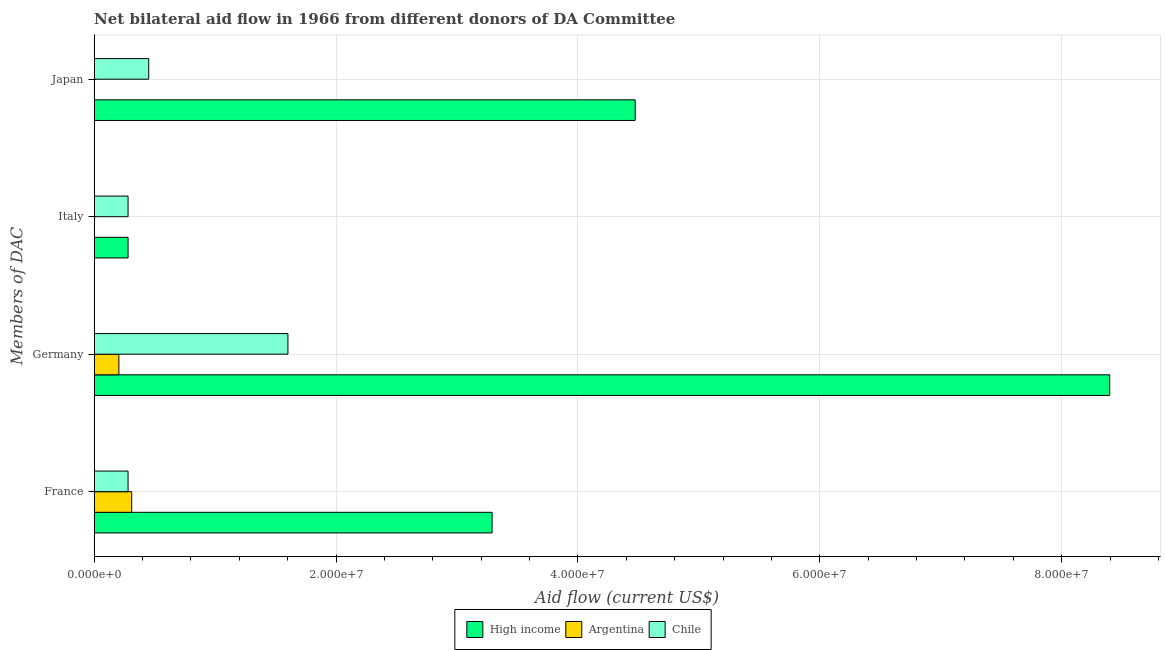Are the number of bars on each tick of the Y-axis equal?
Make the answer very short. No. How many bars are there on the 3rd tick from the top?
Give a very brief answer. 3. How many bars are there on the 2nd tick from the bottom?
Keep it short and to the point. 3. Across all countries, what is the maximum amount of aid given by germany?
Offer a terse response. 8.40e+07. Across all countries, what is the minimum amount of aid given by japan?
Give a very brief answer. 2.00e+04. In which country was the amount of aid given by japan maximum?
Provide a succinct answer. High income. What is the total amount of aid given by germany in the graph?
Keep it short and to the point. 1.02e+08. What is the difference between the amount of aid given by germany in Chile and that in High income?
Your answer should be very brief. -6.80e+07. What is the difference between the amount of aid given by germany in High income and the amount of aid given by italy in Chile?
Provide a short and direct response. 8.12e+07. What is the average amount of aid given by france per country?
Give a very brief answer. 1.29e+07. What is the difference between the amount of aid given by italy and amount of aid given by japan in High income?
Provide a short and direct response. -4.19e+07. In how many countries, is the amount of aid given by japan greater than 44000000 US$?
Provide a succinct answer. 1. Is the difference between the amount of aid given by italy in Chile and High income greater than the difference between the amount of aid given by france in Chile and High income?
Offer a very short reply. Yes. What is the difference between the highest and the second highest amount of aid given by germany?
Offer a terse response. 6.80e+07. What is the difference between the highest and the lowest amount of aid given by france?
Offer a very short reply. 3.01e+07. Is it the case that in every country, the sum of the amount of aid given by italy and amount of aid given by japan is greater than the sum of amount of aid given by france and amount of aid given by germany?
Offer a very short reply. No. Is it the case that in every country, the sum of the amount of aid given by france and amount of aid given by germany is greater than the amount of aid given by italy?
Offer a very short reply. Yes. Are all the bars in the graph horizontal?
Offer a very short reply. Yes. What is the difference between two consecutive major ticks on the X-axis?
Offer a terse response. 2.00e+07. Does the graph contain grids?
Make the answer very short. Yes. Where does the legend appear in the graph?
Make the answer very short. Bottom center. How many legend labels are there?
Make the answer very short. 3. How are the legend labels stacked?
Provide a succinct answer. Horizontal. What is the title of the graph?
Provide a succinct answer. Net bilateral aid flow in 1966 from different donors of DA Committee. Does "Vanuatu" appear as one of the legend labels in the graph?
Offer a terse response. No. What is the label or title of the X-axis?
Provide a short and direct response. Aid flow (current US$). What is the label or title of the Y-axis?
Keep it short and to the point. Members of DAC. What is the Aid flow (current US$) in High income in France?
Your response must be concise. 3.29e+07. What is the Aid flow (current US$) in Argentina in France?
Make the answer very short. 3.10e+06. What is the Aid flow (current US$) of Chile in France?
Your answer should be compact. 2.80e+06. What is the Aid flow (current US$) in High income in Germany?
Your answer should be very brief. 8.40e+07. What is the Aid flow (current US$) in Argentina in Germany?
Offer a very short reply. 2.04e+06. What is the Aid flow (current US$) of Chile in Germany?
Make the answer very short. 1.60e+07. What is the Aid flow (current US$) in High income in Italy?
Offer a terse response. 2.80e+06. What is the Aid flow (current US$) in Chile in Italy?
Give a very brief answer. 2.80e+06. What is the Aid flow (current US$) in High income in Japan?
Keep it short and to the point. 4.47e+07. What is the Aid flow (current US$) of Argentina in Japan?
Your answer should be compact. 2.00e+04. What is the Aid flow (current US$) of Chile in Japan?
Your answer should be compact. 4.51e+06. Across all Members of DAC, what is the maximum Aid flow (current US$) of High income?
Your answer should be compact. 8.40e+07. Across all Members of DAC, what is the maximum Aid flow (current US$) of Argentina?
Your answer should be compact. 3.10e+06. Across all Members of DAC, what is the maximum Aid flow (current US$) of Chile?
Make the answer very short. 1.60e+07. Across all Members of DAC, what is the minimum Aid flow (current US$) of High income?
Offer a terse response. 2.80e+06. Across all Members of DAC, what is the minimum Aid flow (current US$) of Chile?
Give a very brief answer. 2.80e+06. What is the total Aid flow (current US$) in High income in the graph?
Keep it short and to the point. 1.64e+08. What is the total Aid flow (current US$) in Argentina in the graph?
Keep it short and to the point. 5.16e+06. What is the total Aid flow (current US$) in Chile in the graph?
Offer a very short reply. 2.61e+07. What is the difference between the Aid flow (current US$) in High income in France and that in Germany?
Provide a short and direct response. -5.11e+07. What is the difference between the Aid flow (current US$) of Argentina in France and that in Germany?
Offer a very short reply. 1.06e+06. What is the difference between the Aid flow (current US$) in Chile in France and that in Germany?
Your answer should be compact. -1.32e+07. What is the difference between the Aid flow (current US$) in High income in France and that in Italy?
Make the answer very short. 3.01e+07. What is the difference between the Aid flow (current US$) of Chile in France and that in Italy?
Provide a succinct answer. 0. What is the difference between the Aid flow (current US$) of High income in France and that in Japan?
Make the answer very short. -1.18e+07. What is the difference between the Aid flow (current US$) of Argentina in France and that in Japan?
Ensure brevity in your answer.  3.08e+06. What is the difference between the Aid flow (current US$) in Chile in France and that in Japan?
Provide a short and direct response. -1.71e+06. What is the difference between the Aid flow (current US$) of High income in Germany and that in Italy?
Your answer should be very brief. 8.12e+07. What is the difference between the Aid flow (current US$) in Chile in Germany and that in Italy?
Your response must be concise. 1.32e+07. What is the difference between the Aid flow (current US$) in High income in Germany and that in Japan?
Provide a succinct answer. 3.92e+07. What is the difference between the Aid flow (current US$) of Argentina in Germany and that in Japan?
Your answer should be compact. 2.02e+06. What is the difference between the Aid flow (current US$) of Chile in Germany and that in Japan?
Provide a succinct answer. 1.15e+07. What is the difference between the Aid flow (current US$) in High income in Italy and that in Japan?
Make the answer very short. -4.19e+07. What is the difference between the Aid flow (current US$) of Chile in Italy and that in Japan?
Provide a short and direct response. -1.71e+06. What is the difference between the Aid flow (current US$) of High income in France and the Aid flow (current US$) of Argentina in Germany?
Your answer should be very brief. 3.09e+07. What is the difference between the Aid flow (current US$) of High income in France and the Aid flow (current US$) of Chile in Germany?
Provide a succinct answer. 1.69e+07. What is the difference between the Aid flow (current US$) in Argentina in France and the Aid flow (current US$) in Chile in Germany?
Your response must be concise. -1.29e+07. What is the difference between the Aid flow (current US$) in High income in France and the Aid flow (current US$) in Chile in Italy?
Ensure brevity in your answer.  3.01e+07. What is the difference between the Aid flow (current US$) in Argentina in France and the Aid flow (current US$) in Chile in Italy?
Give a very brief answer. 3.00e+05. What is the difference between the Aid flow (current US$) of High income in France and the Aid flow (current US$) of Argentina in Japan?
Give a very brief answer. 3.29e+07. What is the difference between the Aid flow (current US$) in High income in France and the Aid flow (current US$) in Chile in Japan?
Your answer should be very brief. 2.84e+07. What is the difference between the Aid flow (current US$) of Argentina in France and the Aid flow (current US$) of Chile in Japan?
Your answer should be very brief. -1.41e+06. What is the difference between the Aid flow (current US$) in High income in Germany and the Aid flow (current US$) in Chile in Italy?
Ensure brevity in your answer.  8.12e+07. What is the difference between the Aid flow (current US$) in Argentina in Germany and the Aid flow (current US$) in Chile in Italy?
Provide a short and direct response. -7.60e+05. What is the difference between the Aid flow (current US$) of High income in Germany and the Aid flow (current US$) of Argentina in Japan?
Offer a terse response. 8.40e+07. What is the difference between the Aid flow (current US$) of High income in Germany and the Aid flow (current US$) of Chile in Japan?
Give a very brief answer. 7.95e+07. What is the difference between the Aid flow (current US$) of Argentina in Germany and the Aid flow (current US$) of Chile in Japan?
Keep it short and to the point. -2.47e+06. What is the difference between the Aid flow (current US$) in High income in Italy and the Aid flow (current US$) in Argentina in Japan?
Offer a very short reply. 2.78e+06. What is the difference between the Aid flow (current US$) of High income in Italy and the Aid flow (current US$) of Chile in Japan?
Your answer should be very brief. -1.71e+06. What is the average Aid flow (current US$) in High income per Members of DAC?
Offer a very short reply. 4.11e+07. What is the average Aid flow (current US$) in Argentina per Members of DAC?
Make the answer very short. 1.29e+06. What is the average Aid flow (current US$) of Chile per Members of DAC?
Provide a short and direct response. 6.53e+06. What is the difference between the Aid flow (current US$) of High income and Aid flow (current US$) of Argentina in France?
Ensure brevity in your answer.  2.98e+07. What is the difference between the Aid flow (current US$) in High income and Aid flow (current US$) in Chile in France?
Provide a succinct answer. 3.01e+07. What is the difference between the Aid flow (current US$) of High income and Aid flow (current US$) of Argentina in Germany?
Your response must be concise. 8.19e+07. What is the difference between the Aid flow (current US$) in High income and Aid flow (current US$) in Chile in Germany?
Your answer should be compact. 6.80e+07. What is the difference between the Aid flow (current US$) of Argentina and Aid flow (current US$) of Chile in Germany?
Offer a terse response. -1.40e+07. What is the difference between the Aid flow (current US$) in High income and Aid flow (current US$) in Argentina in Japan?
Provide a succinct answer. 4.47e+07. What is the difference between the Aid flow (current US$) of High income and Aid flow (current US$) of Chile in Japan?
Ensure brevity in your answer.  4.02e+07. What is the difference between the Aid flow (current US$) of Argentina and Aid flow (current US$) of Chile in Japan?
Your answer should be compact. -4.49e+06. What is the ratio of the Aid flow (current US$) of High income in France to that in Germany?
Make the answer very short. 0.39. What is the ratio of the Aid flow (current US$) of Argentina in France to that in Germany?
Provide a succinct answer. 1.52. What is the ratio of the Aid flow (current US$) in Chile in France to that in Germany?
Provide a short and direct response. 0.17. What is the ratio of the Aid flow (current US$) of High income in France to that in Italy?
Your response must be concise. 11.75. What is the ratio of the Aid flow (current US$) in High income in France to that in Japan?
Keep it short and to the point. 0.74. What is the ratio of the Aid flow (current US$) in Argentina in France to that in Japan?
Give a very brief answer. 155. What is the ratio of the Aid flow (current US$) in Chile in France to that in Japan?
Provide a succinct answer. 0.62. What is the ratio of the Aid flow (current US$) of High income in Germany to that in Italy?
Ensure brevity in your answer.  29.99. What is the ratio of the Aid flow (current US$) in Chile in Germany to that in Italy?
Offer a very short reply. 5.72. What is the ratio of the Aid flow (current US$) in High income in Germany to that in Japan?
Ensure brevity in your answer.  1.88. What is the ratio of the Aid flow (current US$) of Argentina in Germany to that in Japan?
Ensure brevity in your answer.  102. What is the ratio of the Aid flow (current US$) in Chile in Germany to that in Japan?
Ensure brevity in your answer.  3.55. What is the ratio of the Aid flow (current US$) of High income in Italy to that in Japan?
Provide a short and direct response. 0.06. What is the ratio of the Aid flow (current US$) of Chile in Italy to that in Japan?
Give a very brief answer. 0.62. What is the difference between the highest and the second highest Aid flow (current US$) of High income?
Provide a short and direct response. 3.92e+07. What is the difference between the highest and the second highest Aid flow (current US$) in Argentina?
Ensure brevity in your answer.  1.06e+06. What is the difference between the highest and the second highest Aid flow (current US$) of Chile?
Ensure brevity in your answer.  1.15e+07. What is the difference between the highest and the lowest Aid flow (current US$) in High income?
Keep it short and to the point. 8.12e+07. What is the difference between the highest and the lowest Aid flow (current US$) of Argentina?
Ensure brevity in your answer.  3.10e+06. What is the difference between the highest and the lowest Aid flow (current US$) in Chile?
Provide a succinct answer. 1.32e+07. 